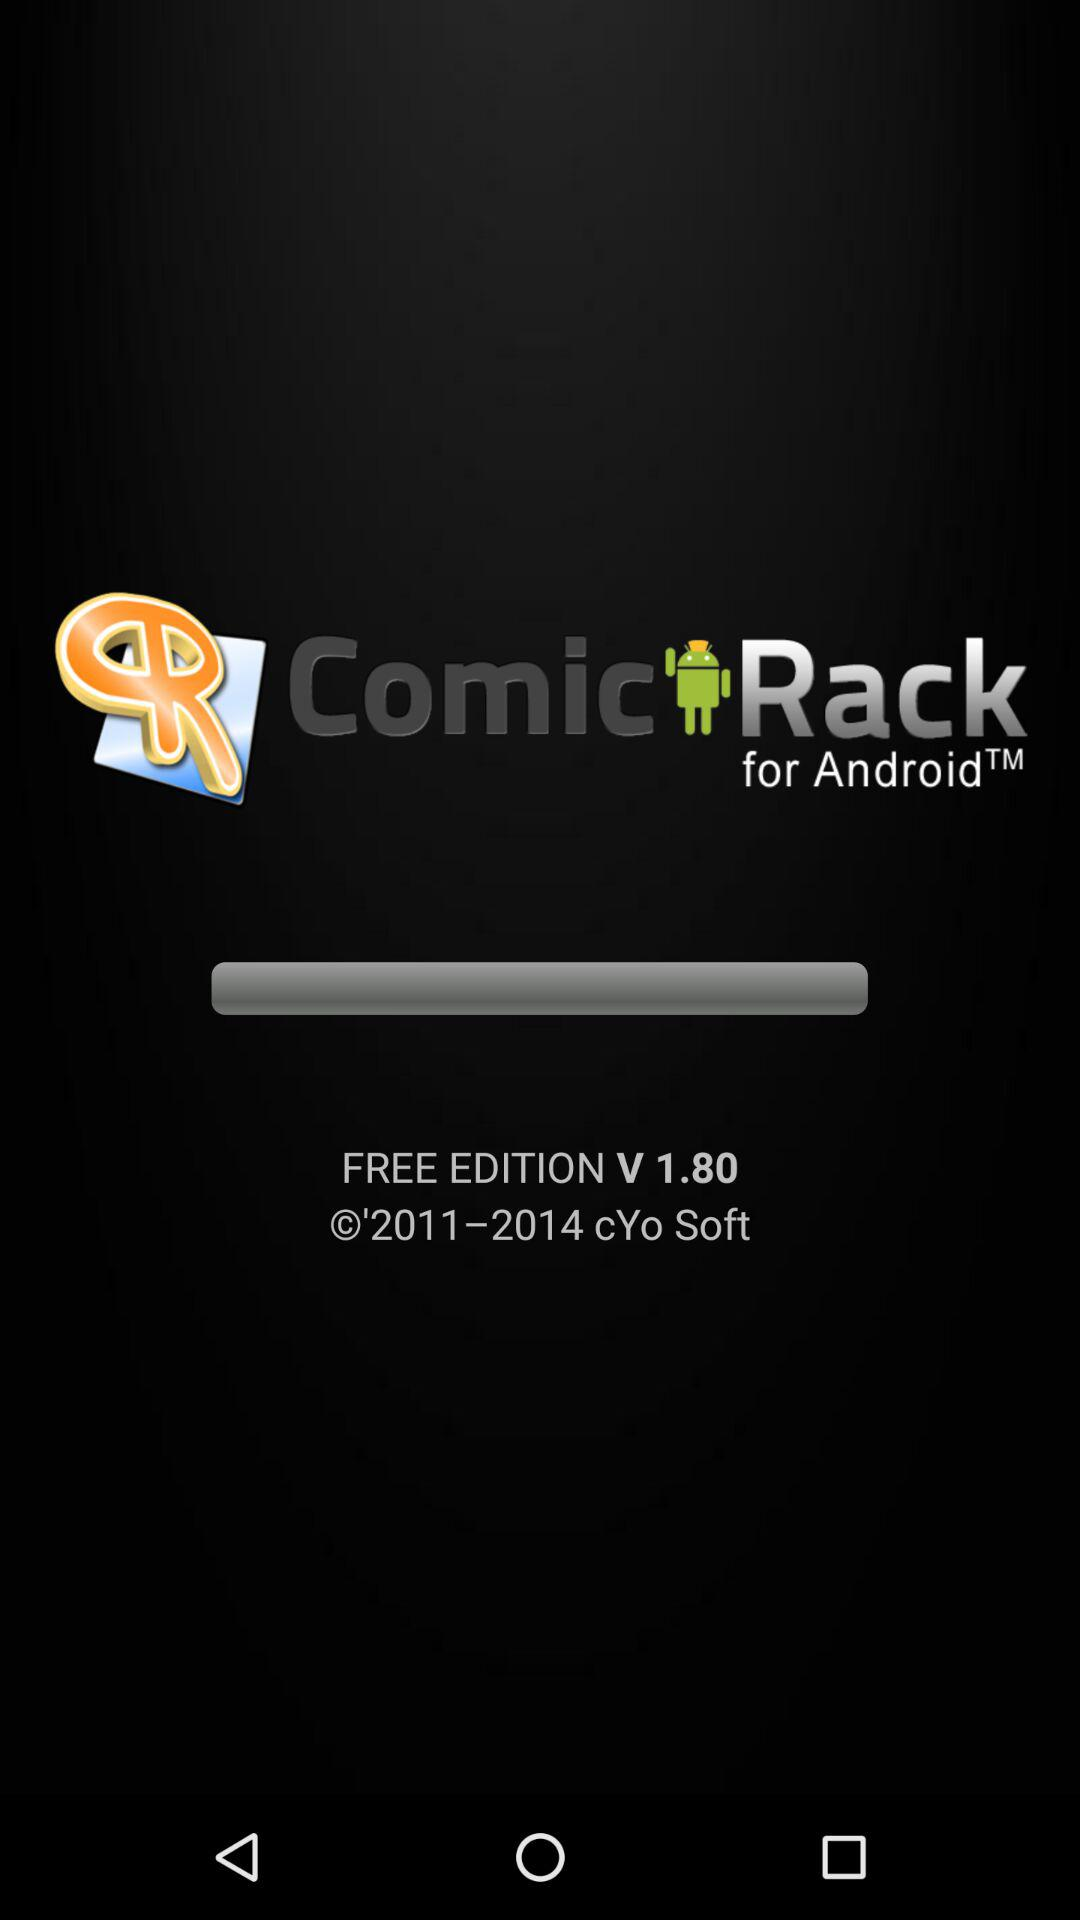Who developed this application?
When the provided information is insufficient, respond with <no answer>. <no answer> 